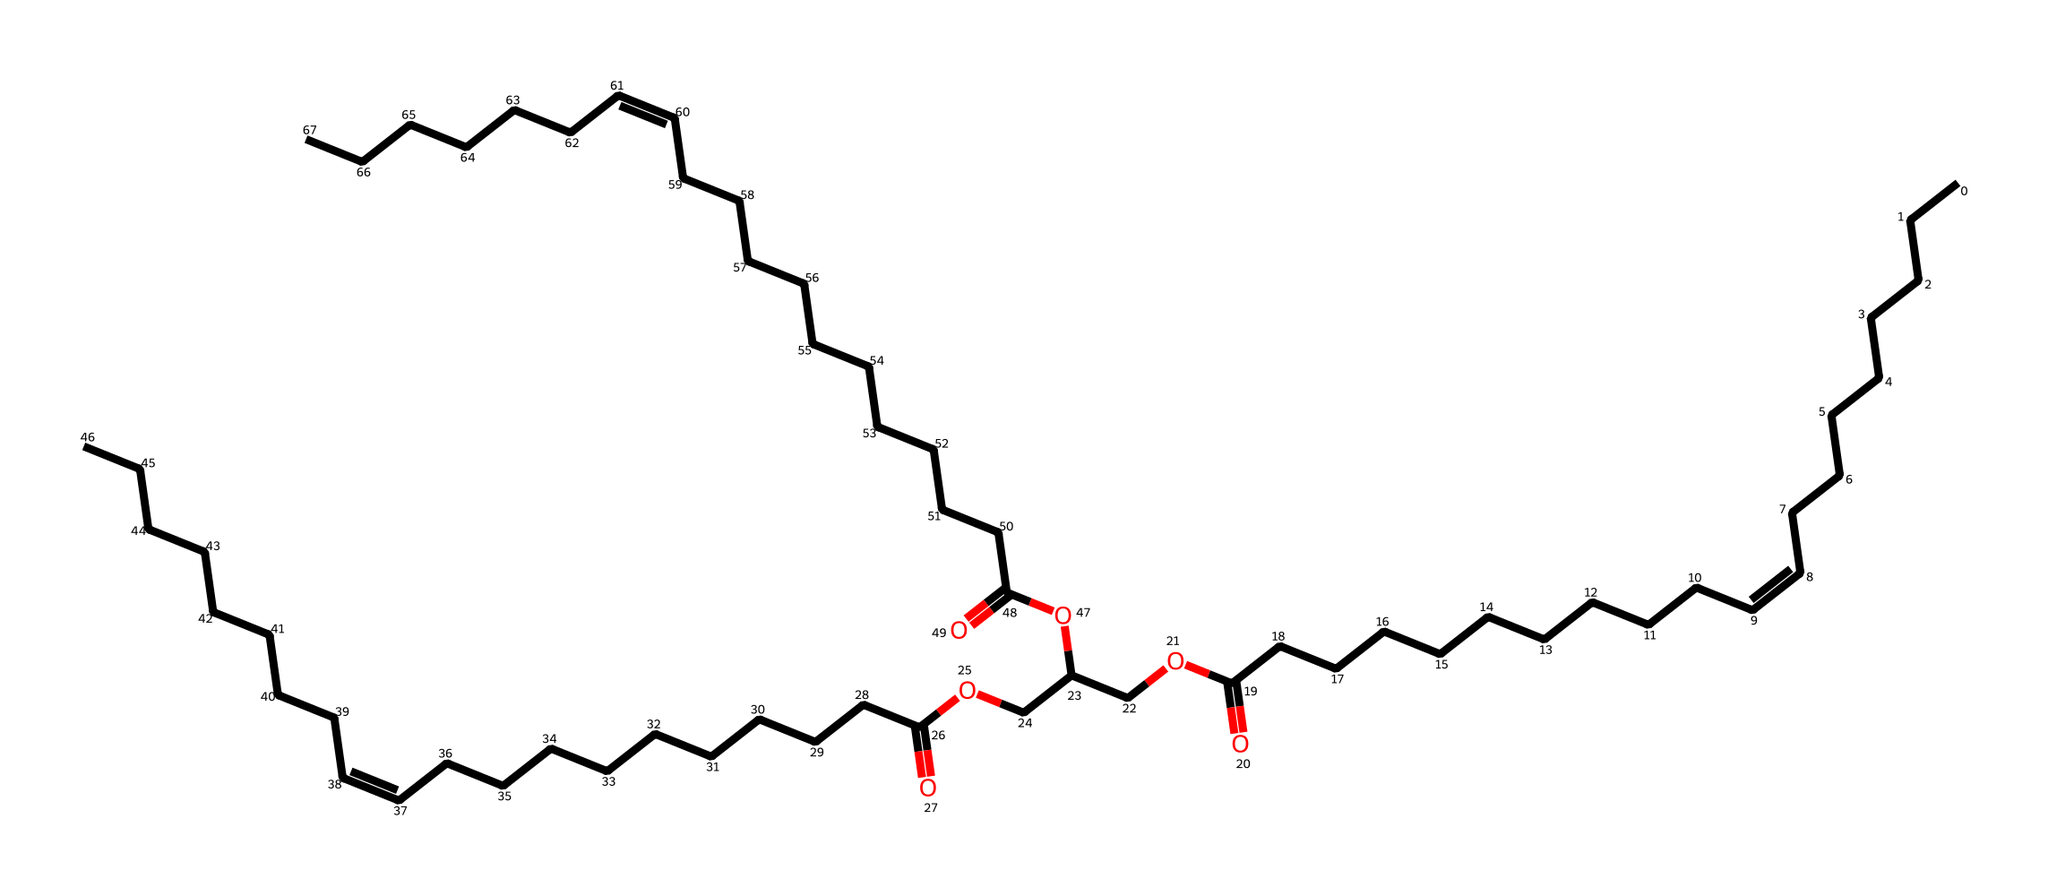How many carbon atoms are present in this chemical structure? By analyzing the SMILES representation, we can count the 'C' characters, which represent carbon atoms. Each section of the hydrocarbon chain contributes carbons, and there are also carbons in functional groups. In total, there are 64 carbon atoms in this lipid molecule.
Answer: 64 What type of functional group is present in this structure? The presence of the 'O' and 'C(=O)' indicates that there are ester and carboxylic acid functional groups. This can be deduced from the patterns seen, where carbon is double bonded to an oxygen (carbonyl) and single bonded to an oxygen (indicating ester formation).
Answer: ester, carboxylic acid How many double bonds are depicted in the structure? The double bonds are indicated by the '/C=C\' notation in the SMILES. By inspecting the representation, there are three pairs of '/C=C\' which signifies three double bonds.
Answer: 3 Which part of the molecule contributes to its fluidity at room temperature? The presence of double bonds in the hydrocarbon chains introduces kinks, preventing tight packing of fatty acids, which is typical for unsaturated lipids. These kinks lead to increased fluidity.
Answer: double bonds Is this lipid likely to be solid or liquid at room temperature? Given the presence of multiple double bonds and the consequent unsaturation, this lipid is more likely to be liquid at room temperature, which is characteristic of oils.
Answer: liquid 